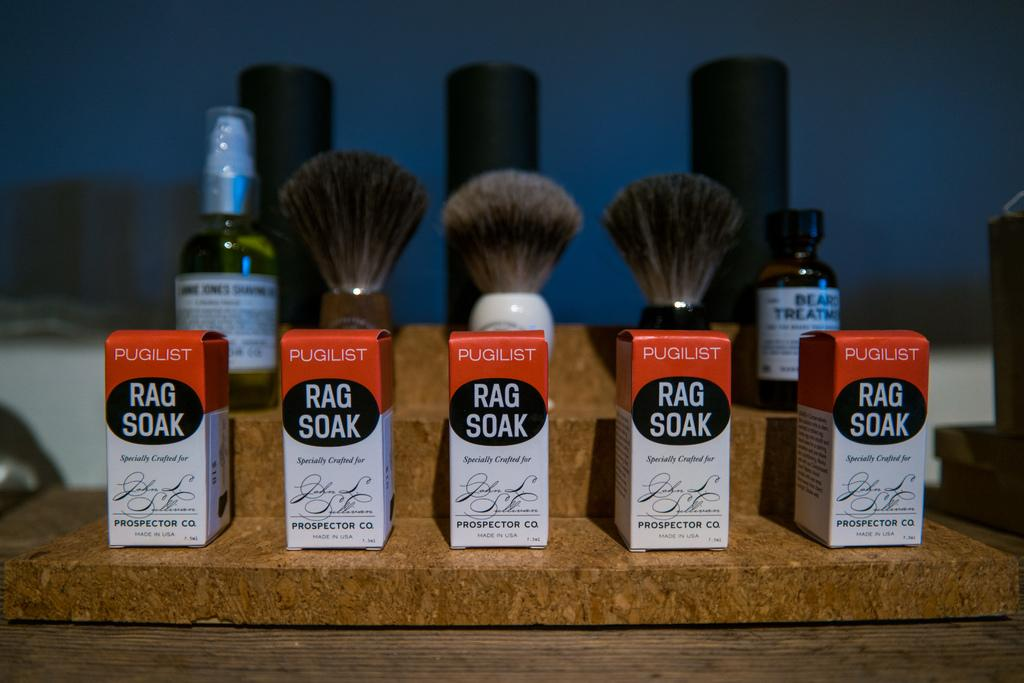<image>
Offer a succinct explanation of the picture presented. Five boxes of RAG SOAK are lined up in a row with some brushes behind them. 